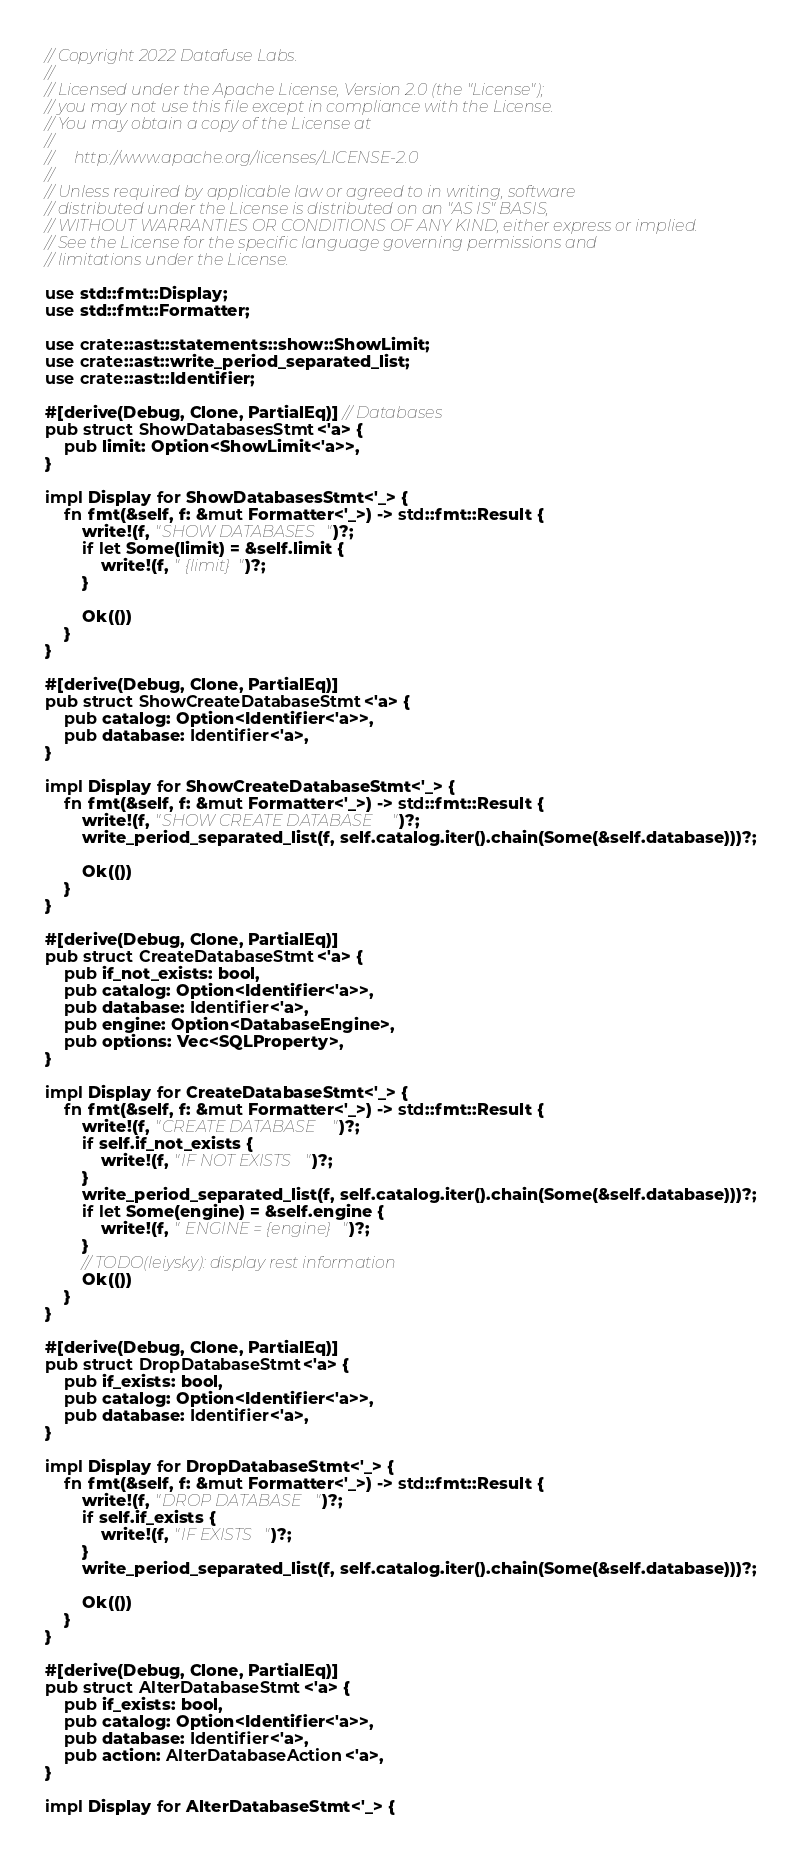<code> <loc_0><loc_0><loc_500><loc_500><_Rust_>// Copyright 2022 Datafuse Labs.
//
// Licensed under the Apache License, Version 2.0 (the "License");
// you may not use this file except in compliance with the License.
// You may obtain a copy of the License at
//
//     http://www.apache.org/licenses/LICENSE-2.0
//
// Unless required by applicable law or agreed to in writing, software
// distributed under the License is distributed on an "AS IS" BASIS,
// WITHOUT WARRANTIES OR CONDITIONS OF ANY KIND, either express or implied.
// See the License for the specific language governing permissions and
// limitations under the License.

use std::fmt::Display;
use std::fmt::Formatter;

use crate::ast::statements::show::ShowLimit;
use crate::ast::write_period_separated_list;
use crate::ast::Identifier;

#[derive(Debug, Clone, PartialEq)] // Databases
pub struct ShowDatabasesStmt<'a> {
    pub limit: Option<ShowLimit<'a>>,
}

impl Display for ShowDatabasesStmt<'_> {
    fn fmt(&self, f: &mut Formatter<'_>) -> std::fmt::Result {
        write!(f, "SHOW DATABASES")?;
        if let Some(limit) = &self.limit {
            write!(f, " {limit}")?;
        }

        Ok(())
    }
}

#[derive(Debug, Clone, PartialEq)]
pub struct ShowCreateDatabaseStmt<'a> {
    pub catalog: Option<Identifier<'a>>,
    pub database: Identifier<'a>,
}

impl Display for ShowCreateDatabaseStmt<'_> {
    fn fmt(&self, f: &mut Formatter<'_>) -> std::fmt::Result {
        write!(f, "SHOW CREATE DATABASE ")?;
        write_period_separated_list(f, self.catalog.iter().chain(Some(&self.database)))?;

        Ok(())
    }
}

#[derive(Debug, Clone, PartialEq)]
pub struct CreateDatabaseStmt<'a> {
    pub if_not_exists: bool,
    pub catalog: Option<Identifier<'a>>,
    pub database: Identifier<'a>,
    pub engine: Option<DatabaseEngine>,
    pub options: Vec<SQLProperty>,
}

impl Display for CreateDatabaseStmt<'_> {
    fn fmt(&self, f: &mut Formatter<'_>) -> std::fmt::Result {
        write!(f, "CREATE DATABASE ")?;
        if self.if_not_exists {
            write!(f, "IF NOT EXISTS ")?;
        }
        write_period_separated_list(f, self.catalog.iter().chain(Some(&self.database)))?;
        if let Some(engine) = &self.engine {
            write!(f, " ENGINE = {engine}")?;
        }
        // TODO(leiysky): display rest information
        Ok(())
    }
}

#[derive(Debug, Clone, PartialEq)]
pub struct DropDatabaseStmt<'a> {
    pub if_exists: bool,
    pub catalog: Option<Identifier<'a>>,
    pub database: Identifier<'a>,
}

impl Display for DropDatabaseStmt<'_> {
    fn fmt(&self, f: &mut Formatter<'_>) -> std::fmt::Result {
        write!(f, "DROP DATABASE ")?;
        if self.if_exists {
            write!(f, "IF EXISTS ")?;
        }
        write_period_separated_list(f, self.catalog.iter().chain(Some(&self.database)))?;

        Ok(())
    }
}

#[derive(Debug, Clone, PartialEq)]
pub struct AlterDatabaseStmt<'a> {
    pub if_exists: bool,
    pub catalog: Option<Identifier<'a>>,
    pub database: Identifier<'a>,
    pub action: AlterDatabaseAction<'a>,
}

impl Display for AlterDatabaseStmt<'_> {</code> 